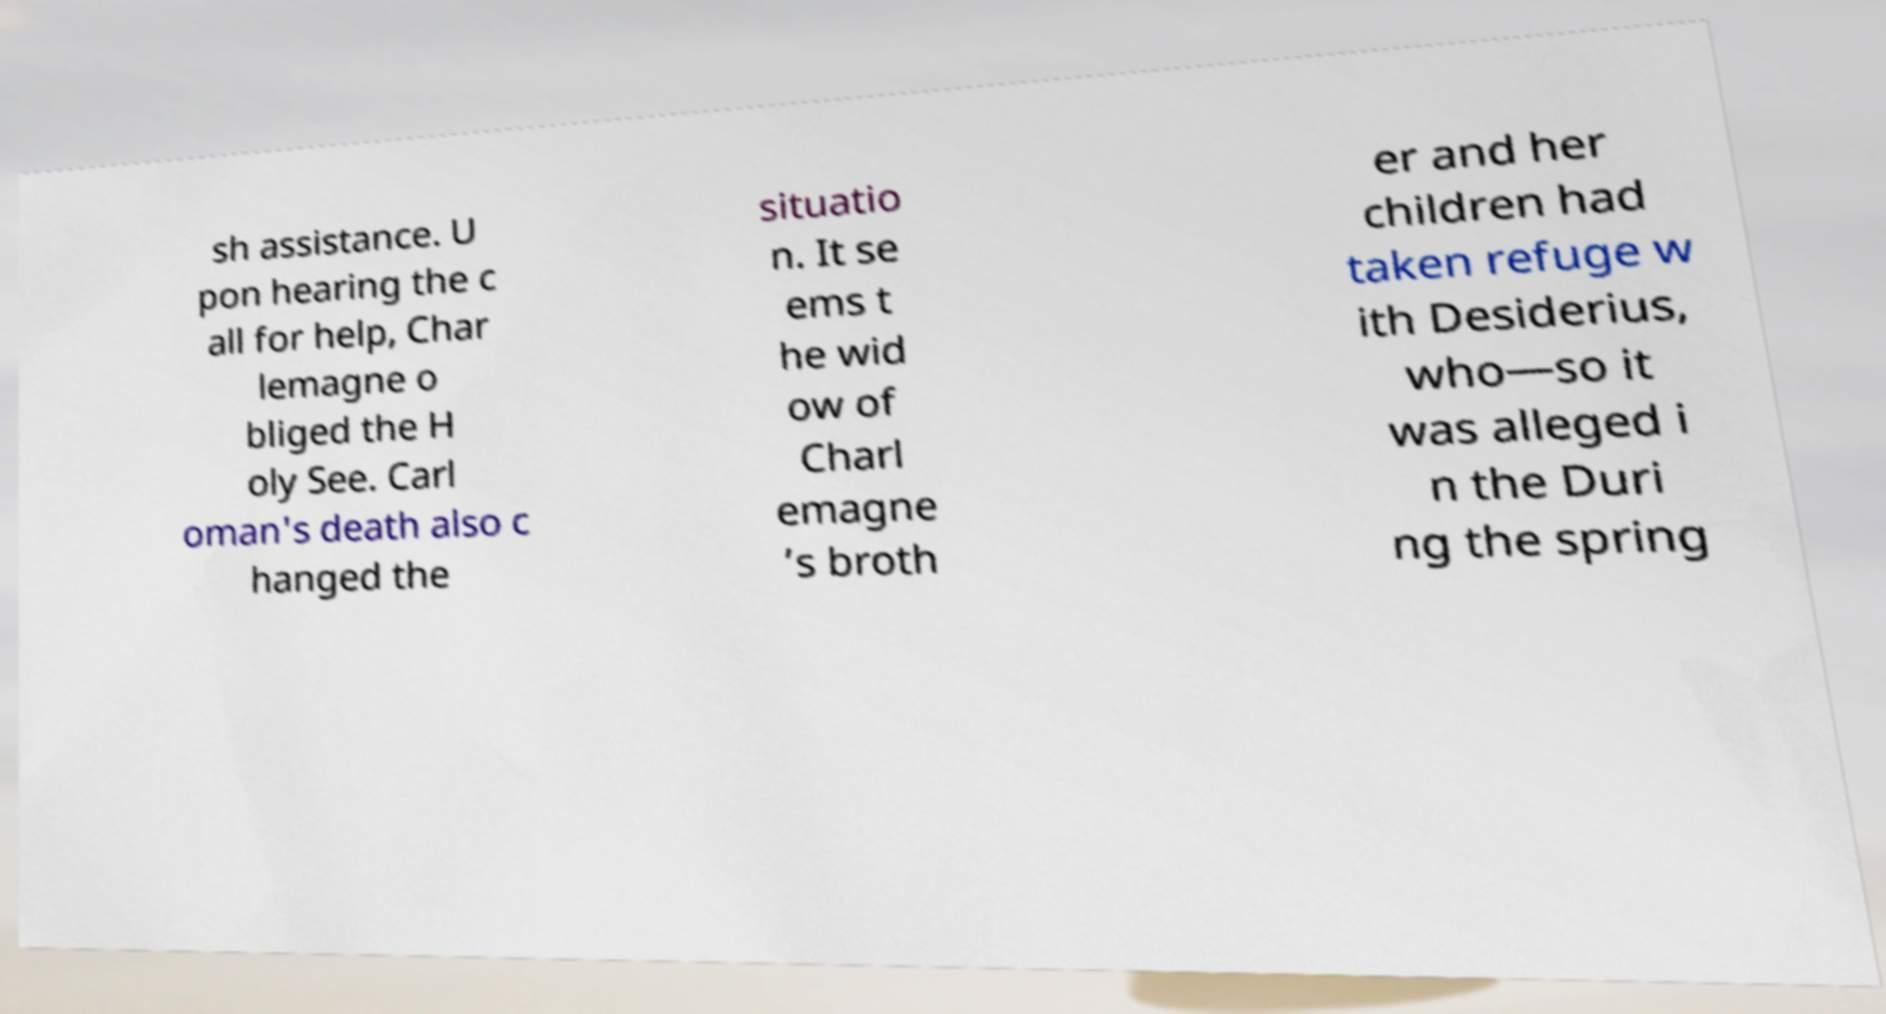What messages or text are displayed in this image? I need them in a readable, typed format. sh assistance. U pon hearing the c all for help, Char lemagne o bliged the H oly See. Carl oman's death also c hanged the situatio n. It se ems t he wid ow of Charl emagne ’s broth er and her children had taken refuge w ith Desiderius, who—so it was alleged i n the Duri ng the spring 